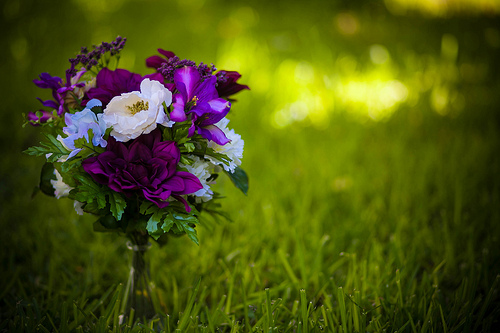<image>
Is there a flower above the grass? Yes. The flower is positioned above the grass in the vertical space, higher up in the scene. 